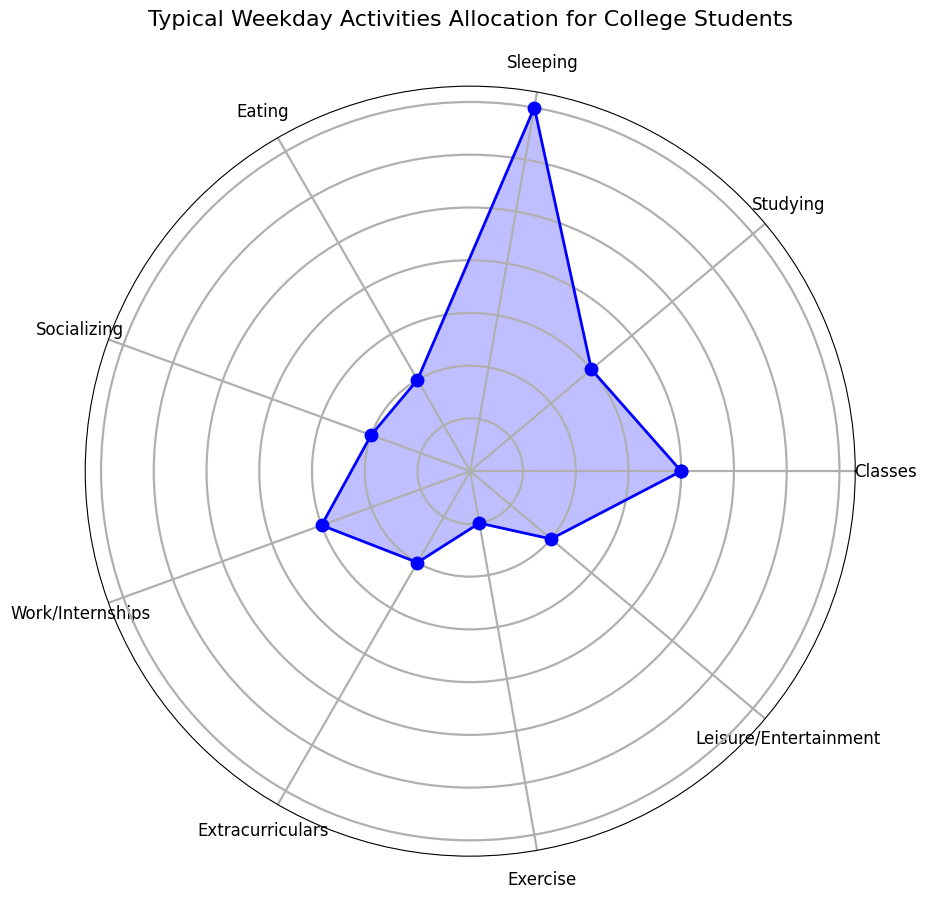Which activity do college students spend the most time on during a typical weekday? By looking at the lengths of the segments in the rose chart, we can see that the segment for 'Sleeping' extends the furthest out from the center, indicating that college students spend the most time on this activity.
Answer: Sleeping How many total hours do college students spend on Extracurriculars, Exercise, and Leisure/Entertainment combined? The respective times for 'Extracurriculars', 'Exercise', and 'Leisure/Entertainment' are 2, 1, and 2 hours. Summing them gives 2 + 1 + 2 = 5 hours.
Answer: 5 hours What is the difference in time spent between Classes and Studying? The time spent on 'Classes' is 4 hours, while the time spent on 'Studying' is 3 hours. The difference in time is 4 - 3 = 1 hour.
Answer: 1 hour Do college students spend more time Socializing or Eating? By comparing the lengths of the segments, both 'Socializing' and 'Eating' have the same length. Thus, college students spend an equal amount of time on these activities.
Answer: Equal Which activities have the same duration of 2 hours? Checking the segments, the activities 'Eating', 'Socializing', 'Extracurriculars', and 'Leisure/Entertainment' all have segments that are the same length, indicating they each take 2 hours.
Answer: Eating, Socializing, Extracurriculars, Leisure/Entertainment What is the total number of hours allocated to Studying and Work/Internships? The time for 'Studying' is 3 hours and for 'Work/Internships' is also 3 hours. Summing them, we get 3 + 3 = 6 hours.
Answer: 6 hours How much more time do college students spend on Sleeping compared to Exercise? The time spent on 'Sleeping' is 7 hours, while 'Exercise' is 1 hour. The difference is 7 - 1 = 6 hours.
Answer: 6 hours Which activity do college students spend the least time on? By observing the rose chart, the segment for 'Exercise' is the shortest, indicating students spend the least time on this activity.
Answer: Exercise What is the ratio of time spent on Classes to time spent on Leisure/Entertainment? Time spent on 'Classes' is 4 hours, while 'Leisure/Entertainment' is 2 hours. The ratio is 4:2, which simplifies to 2:1.
Answer: 2:1 How many times more do college students spend on Sleeping than on Exercise? The time spent on 'Sleeping' is 7 hours, and on 'Exercise' is 1 hour. The ratio is 7:1, meaning students spend 7 times more on Sleeping than Exercise.
Answer: 7 times 